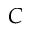Convert formula to latex. <formula><loc_0><loc_0><loc_500><loc_500>C</formula> 